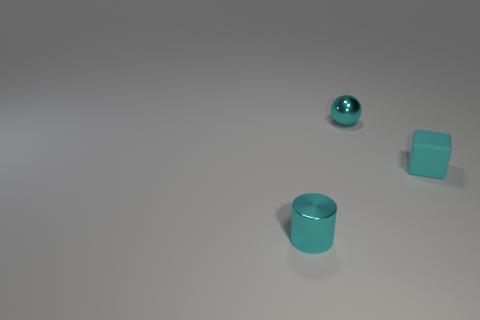There is a cyan rubber object; is its shape the same as the thing that is behind the cube?
Make the answer very short. No. How many small objects are both left of the cube and to the right of the tiny cyan cylinder?
Ensure brevity in your answer.  1. How many other objects are there of the same size as the cube?
Provide a short and direct response. 2. Are there the same number of things that are on the right side of the small cyan cylinder and shiny objects?
Your answer should be very brief. Yes. There is a tiny shiny object in front of the small matte thing; is its color the same as the metallic thing that is behind the metallic cylinder?
Provide a short and direct response. Yes. The object that is on the left side of the tiny cyan rubber cube and behind the tiny cyan cylinder is made of what material?
Your response must be concise. Metal. The small matte block is what color?
Ensure brevity in your answer.  Cyan. What number of other things are there of the same shape as the tiny cyan matte thing?
Keep it short and to the point. 0. Is the number of small metallic spheres in front of the tiny cyan shiny cylinder the same as the number of cyan balls to the left of the cyan metallic ball?
Provide a succinct answer. Yes. What material is the cylinder?
Ensure brevity in your answer.  Metal. 